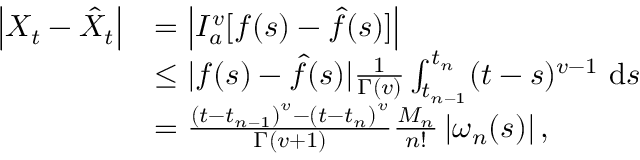<formula> <loc_0><loc_0><loc_500><loc_500>\begin{array} { r l } { \left | X _ { t } - \hat { X } _ { t } \right | } & { = \left | I _ { a } ^ { v } [ f ( s ) - \hat { f } ( s ) ] \right | } \\ & { \leq | f ( s ) - \hat { f } ( s ) | \frac { 1 } { \Gamma ( v ) } \int _ { t _ { n - 1 } } ^ { t _ { n } } ( t - s ) ^ { v - 1 } d s } \\ & { = \frac { \left ( t - t _ { n - 1 } \right ) ^ { v } - \left ( t - t _ { n } \right ) ^ { v } } { \Gamma ( v + 1 ) } \frac { M _ { n } } { n ! } \left | \omega _ { n } ( s ) \right | , } \end{array}</formula> 